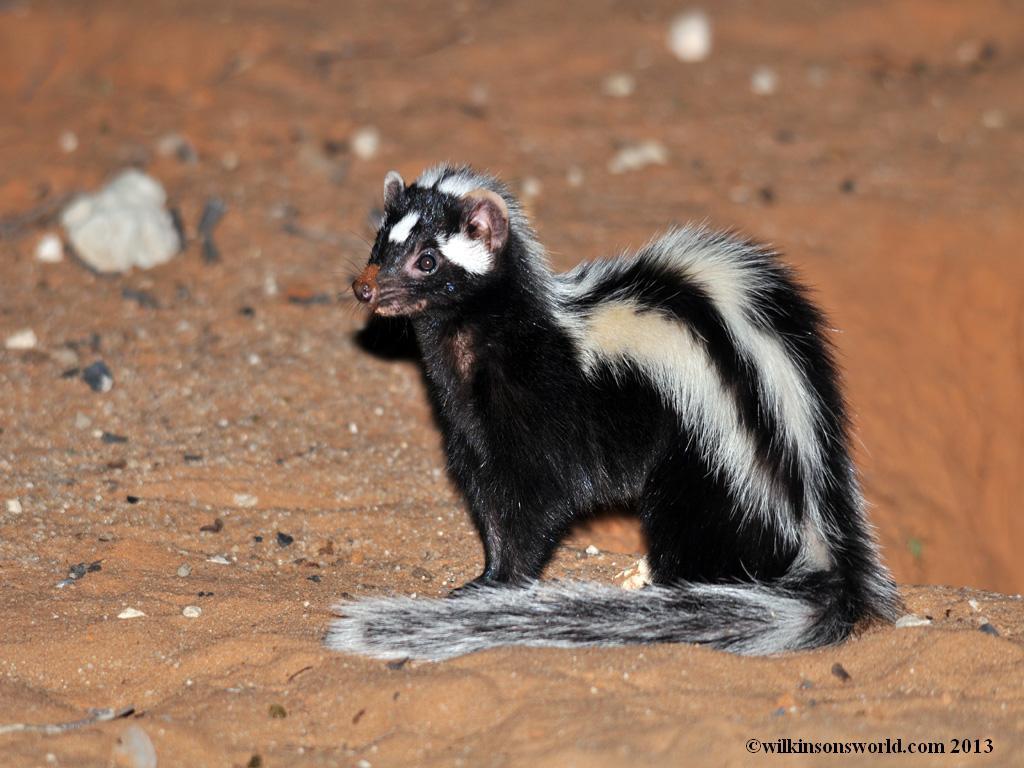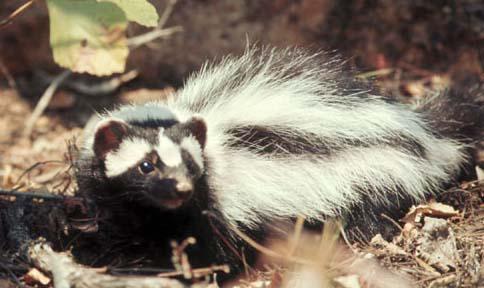The first image is the image on the left, the second image is the image on the right. Given the left and right images, does the statement "The back of one of the skunks is arched upwards." hold true? Answer yes or no. Yes. The first image is the image on the left, the second image is the image on the right. Given the left and right images, does the statement "Both skunks are pointed in the same direction." hold true? Answer yes or no. No. 